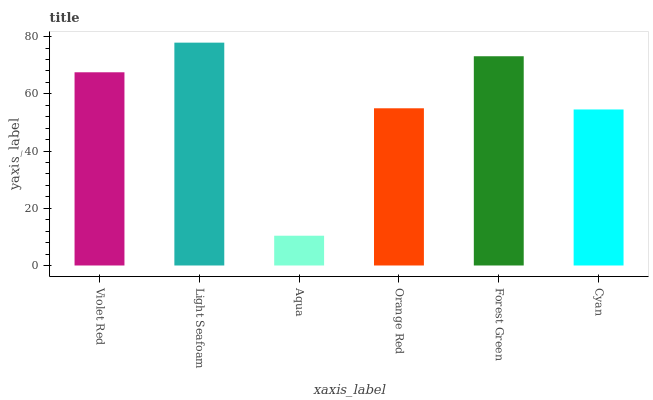Is Light Seafoam the minimum?
Answer yes or no. No. Is Aqua the maximum?
Answer yes or no. No. Is Light Seafoam greater than Aqua?
Answer yes or no. Yes. Is Aqua less than Light Seafoam?
Answer yes or no. Yes. Is Aqua greater than Light Seafoam?
Answer yes or no. No. Is Light Seafoam less than Aqua?
Answer yes or no. No. Is Violet Red the high median?
Answer yes or no. Yes. Is Orange Red the low median?
Answer yes or no. Yes. Is Forest Green the high median?
Answer yes or no. No. Is Cyan the low median?
Answer yes or no. No. 